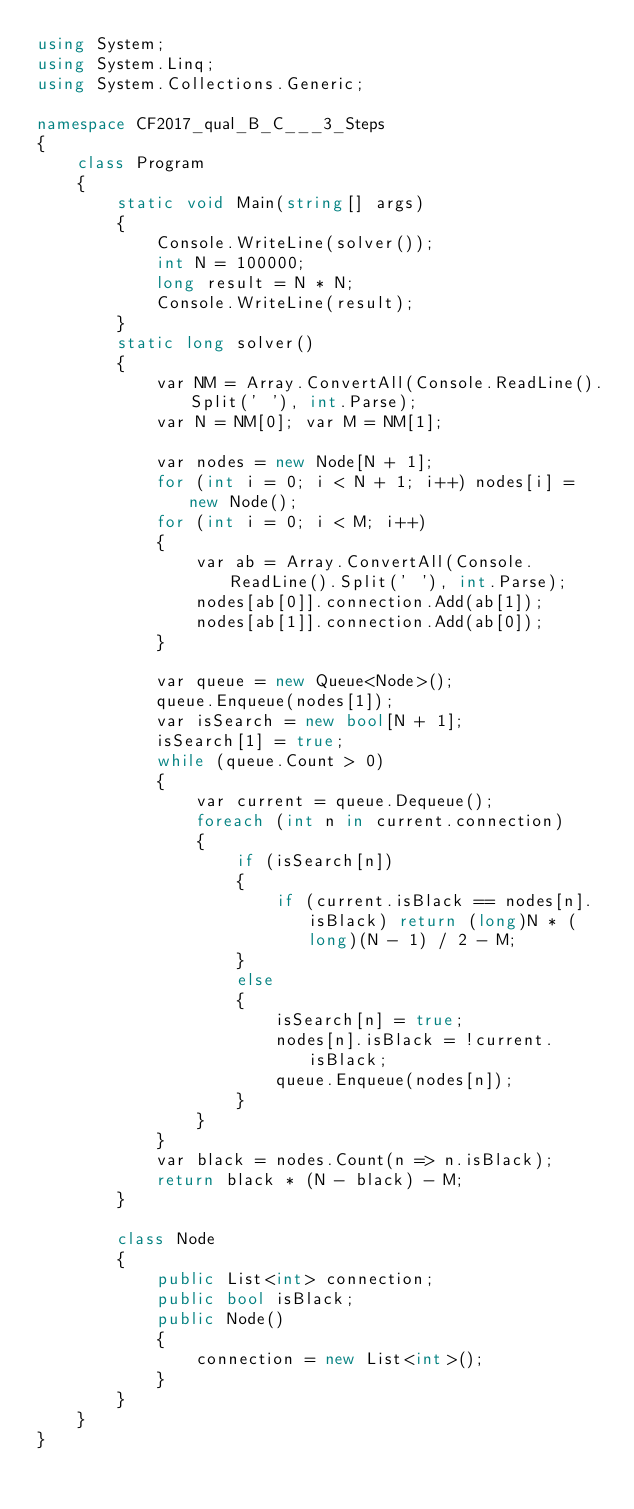<code> <loc_0><loc_0><loc_500><loc_500><_C#_>using System;
using System.Linq;
using System.Collections.Generic;

namespace CF2017_qual_B_C___3_Steps
{
    class Program
    {
        static void Main(string[] args)
        {
            Console.WriteLine(solver());
            int N = 100000;
            long result = N * N;
            Console.WriteLine(result);
        }
        static long solver()
        {
            var NM = Array.ConvertAll(Console.ReadLine().Split(' '), int.Parse);
            var N = NM[0]; var M = NM[1];

            var nodes = new Node[N + 1];
            for (int i = 0; i < N + 1; i++) nodes[i] = new Node();
            for (int i = 0; i < M; i++)
            {
                var ab = Array.ConvertAll(Console.ReadLine().Split(' '), int.Parse);
                nodes[ab[0]].connection.Add(ab[1]);
                nodes[ab[1]].connection.Add(ab[0]);
            }

            var queue = new Queue<Node>();
            queue.Enqueue(nodes[1]);
            var isSearch = new bool[N + 1];
            isSearch[1] = true;
            while (queue.Count > 0)
            {
                var current = queue.Dequeue();
                foreach (int n in current.connection)
                {
                    if (isSearch[n])
                    {
                        if (current.isBlack == nodes[n].isBlack) return (long)N * (long)(N - 1) / 2 - M;
                    }
                    else
                    {
                        isSearch[n] = true;
                        nodes[n].isBlack = !current.isBlack;
                        queue.Enqueue(nodes[n]);
                    }
                }
            }
            var black = nodes.Count(n => n.isBlack);
            return black * (N - black) - M;
        }

        class Node
        {
            public List<int> connection;
            public bool isBlack;
            public Node()
            {
                connection = new List<int>();
            }
        }
    }
}
</code> 